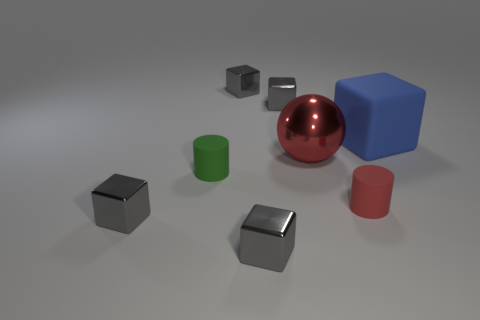Is there any other thing that has the same size as the matte block?
Provide a short and direct response. Yes. Is the number of cylinders in front of the large red sphere less than the number of large cyan things?
Offer a terse response. No. Is the shape of the large red metal object the same as the small green rubber object?
Give a very brief answer. No. There is another tiny thing that is the same shape as the small green matte thing; what is its color?
Your response must be concise. Red. How many large metallic things are the same color as the big rubber object?
Provide a short and direct response. 0. How many things are tiny gray things that are behind the tiny red cylinder or tiny red cylinders?
Provide a succinct answer. 3. There is a cylinder that is left of the red matte cylinder; what is its size?
Give a very brief answer. Small. Is the number of tiny things less than the number of large metal cubes?
Offer a very short reply. No. Is the block to the right of the large sphere made of the same material as the big thing in front of the large blue thing?
Provide a succinct answer. No. There is a small rubber object that is behind the matte cylinder that is right of the matte object on the left side of the small red cylinder; what shape is it?
Make the answer very short. Cylinder. 